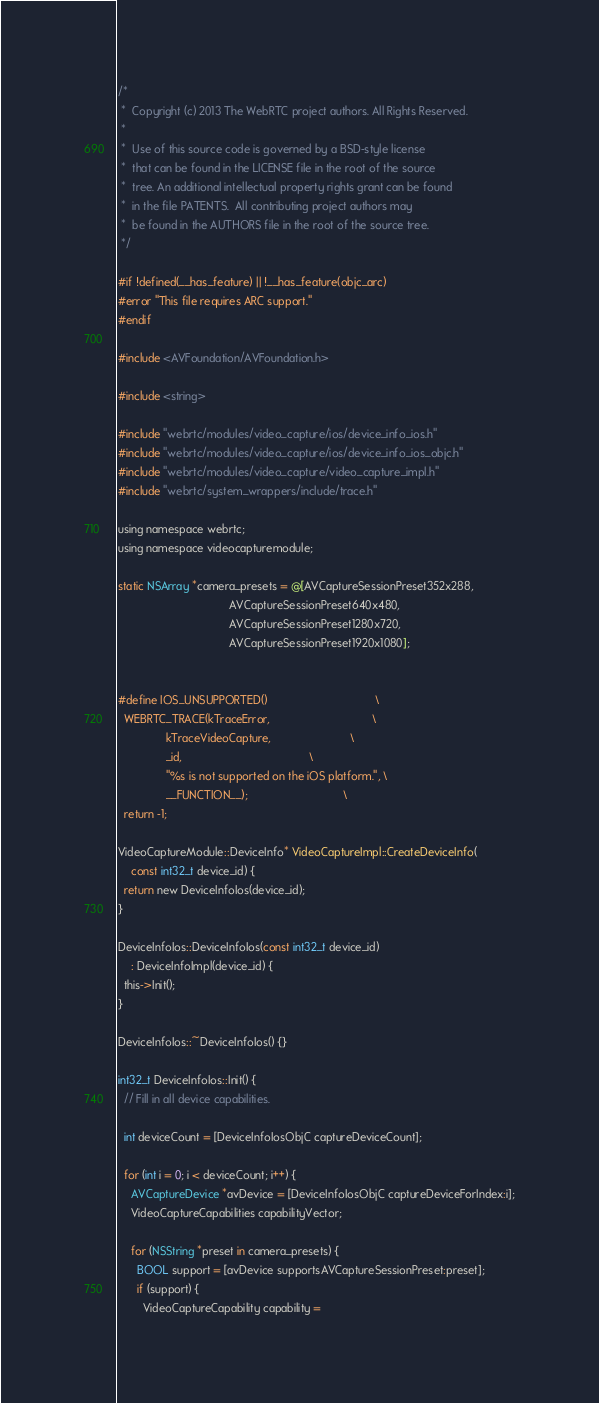<code> <loc_0><loc_0><loc_500><loc_500><_ObjectiveC_>/*
 *  Copyright (c) 2013 The WebRTC project authors. All Rights Reserved.
 *
 *  Use of this source code is governed by a BSD-style license
 *  that can be found in the LICENSE file in the root of the source
 *  tree. An additional intellectual property rights grant can be found
 *  in the file PATENTS.  All contributing project authors may
 *  be found in the AUTHORS file in the root of the source tree.
 */

#if !defined(__has_feature) || !__has_feature(objc_arc)
#error "This file requires ARC support."
#endif

#include <AVFoundation/AVFoundation.h>

#include <string>

#include "webrtc/modules/video_capture/ios/device_info_ios.h"
#include "webrtc/modules/video_capture/ios/device_info_ios_objc.h"
#include "webrtc/modules/video_capture/video_capture_impl.h"
#include "webrtc/system_wrappers/include/trace.h"

using namespace webrtc;
using namespace videocapturemodule;

static NSArray *camera_presets = @[AVCaptureSessionPreset352x288,
                                   AVCaptureSessionPreset640x480,
                                   AVCaptureSessionPreset1280x720,
                                   AVCaptureSessionPreset1920x1080];


#define IOS_UNSUPPORTED()                                  \
  WEBRTC_TRACE(kTraceError,                                \
               kTraceVideoCapture,                         \
               _id,                                        \
               "%s is not supported on the iOS platform.", \
               __FUNCTION__);                              \
  return -1;

VideoCaptureModule::DeviceInfo* VideoCaptureImpl::CreateDeviceInfo(
    const int32_t device_id) {
  return new DeviceInfoIos(device_id);
}

DeviceInfoIos::DeviceInfoIos(const int32_t device_id)
    : DeviceInfoImpl(device_id) {
  this->Init();
}

DeviceInfoIos::~DeviceInfoIos() {}

int32_t DeviceInfoIos::Init() {
  // Fill in all device capabilities.

  int deviceCount = [DeviceInfoIosObjC captureDeviceCount];

  for (int i = 0; i < deviceCount; i++) {
    AVCaptureDevice *avDevice = [DeviceInfoIosObjC captureDeviceForIndex:i];
    VideoCaptureCapabilities capabilityVector;

    for (NSString *preset in camera_presets) {
      BOOL support = [avDevice supportsAVCaptureSessionPreset:preset];
      if (support) {
        VideoCaptureCapability capability =</code> 